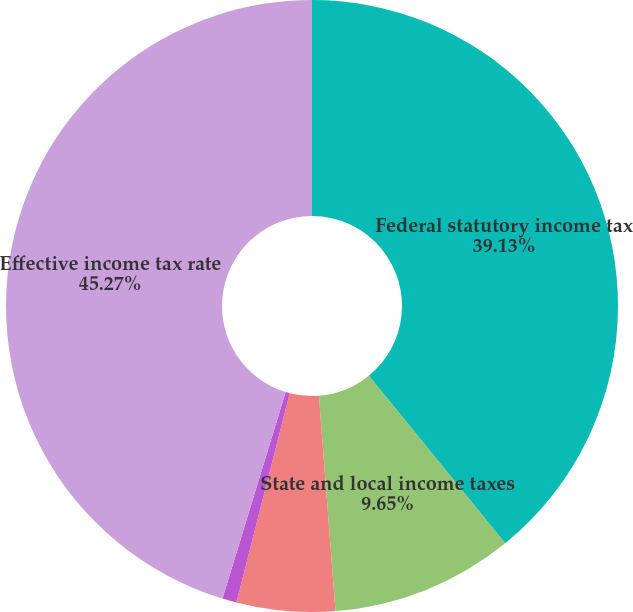Convert chart to OTSL. <chart><loc_0><loc_0><loc_500><loc_500><pie_chart><fcel>Federal statutory income tax<fcel>State and local income taxes<fcel>Nondeductible and other items<fcel>Credits<fcel>Effective income tax rate<nl><fcel>39.13%<fcel>9.65%<fcel>5.2%<fcel>0.75%<fcel>45.28%<nl></chart> 